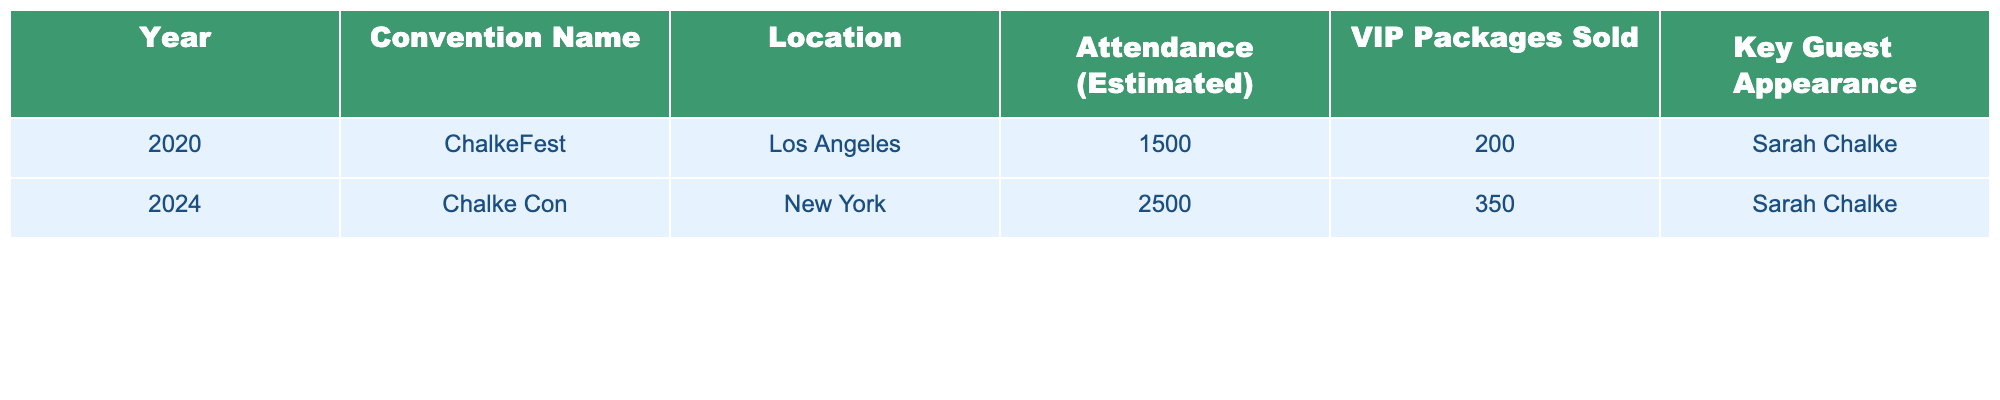What was the estimated attendance at ChalkeFest? The table lists the estimated attendance for ChalkeFest as 1500.
Answer: 1500 What is the location of the Chalke Con? According to the table, Chalke Con is located in New York.
Answer: New York How many VIP packages were sold at the 2024 convention? The table indicates that 350 VIP packages were sold at Chalke Con in 2024.
Answer: 350 What is the difference in attendance between ChalkeFest and Chalke Con? ChalkeFest had an attendance of 1500 and Chalke Con had an attendance of 2500. The difference is 2500 - 1500 = 1000.
Answer: 1000 How many total VIP packages were sold across both conventions? ChalkeFest sold 200 VIP packages and Chalke Con sold 350. The total is 200 + 350 = 550.
Answer: 550 Is it true that Sarah Chalke appeared as a key guest at all the listed conventions? The table shows Sarah Chalke as the key guest appearance for both ChalkeFest and Chalke Con. Therefore, the statement is true.
Answer: True Which convention had the highest estimated attendance? By comparing the attendances, Chalke Con with 2500 attendees has the highest attendance compared to ChalkeFest with 1500 attendees.
Answer: Chalke Con What is the average attendance of the two conventions? The total attendance is 1500 + 2500 = 4000. There are 2 conventions, so the average is 4000 / 2 = 2000.
Answer: 2000 Was the number of VIP packages sold higher at Chalke Con than at ChalkeFest? Chalke Con sold 350 VIP packages while ChalkeFest sold 200, which means Chalke Con had more VIP packages sold.
Answer: Yes If we consider only the VIP packages sold at ChalkeFest, what percentage does it represent of the total VIP packages sold at both conventions? The total VIP packages sold is 550 (200 at ChalkeFest and 350 at Chalke Con). The percentage from ChalkeFest is (200 / 550) * 100 ≈ 36.36%.
Answer: Approximately 36.36% 